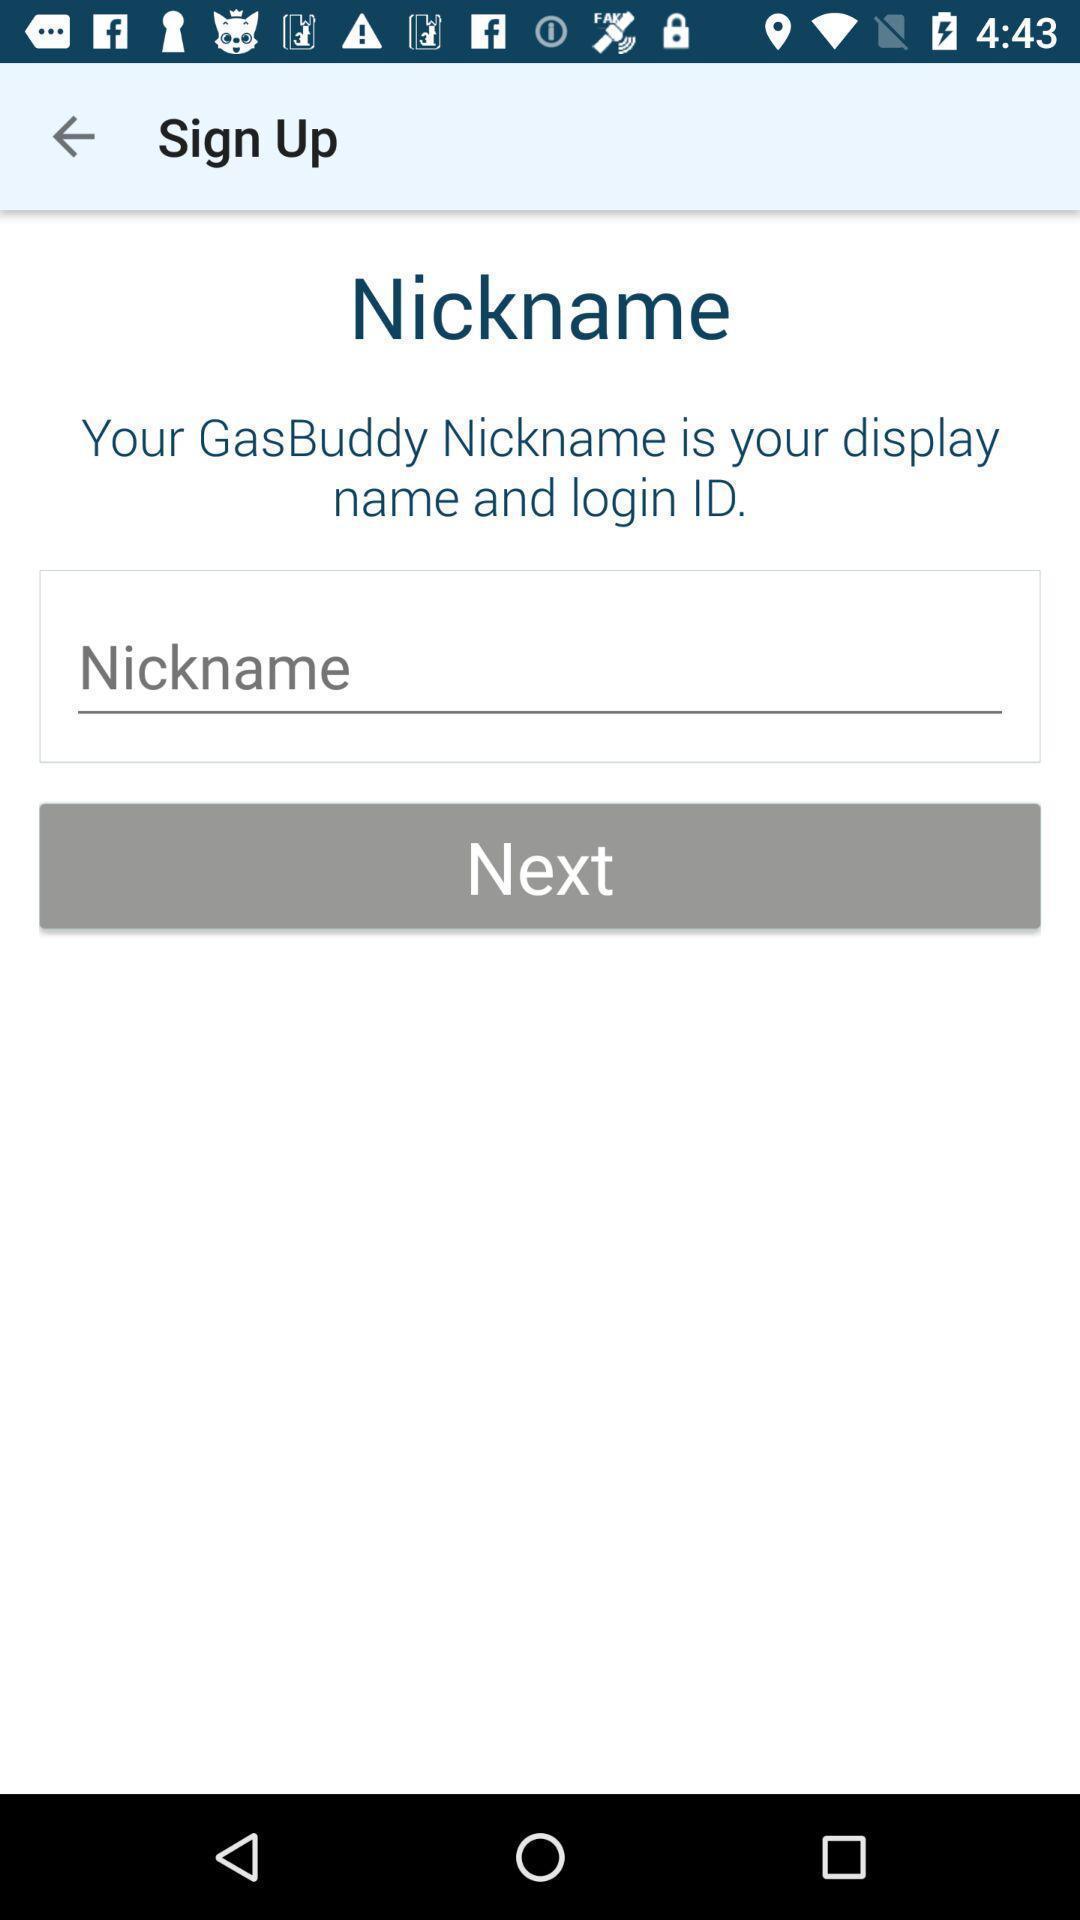Explain the elements present in this screenshot. Signup page for the fuel purchase app. 